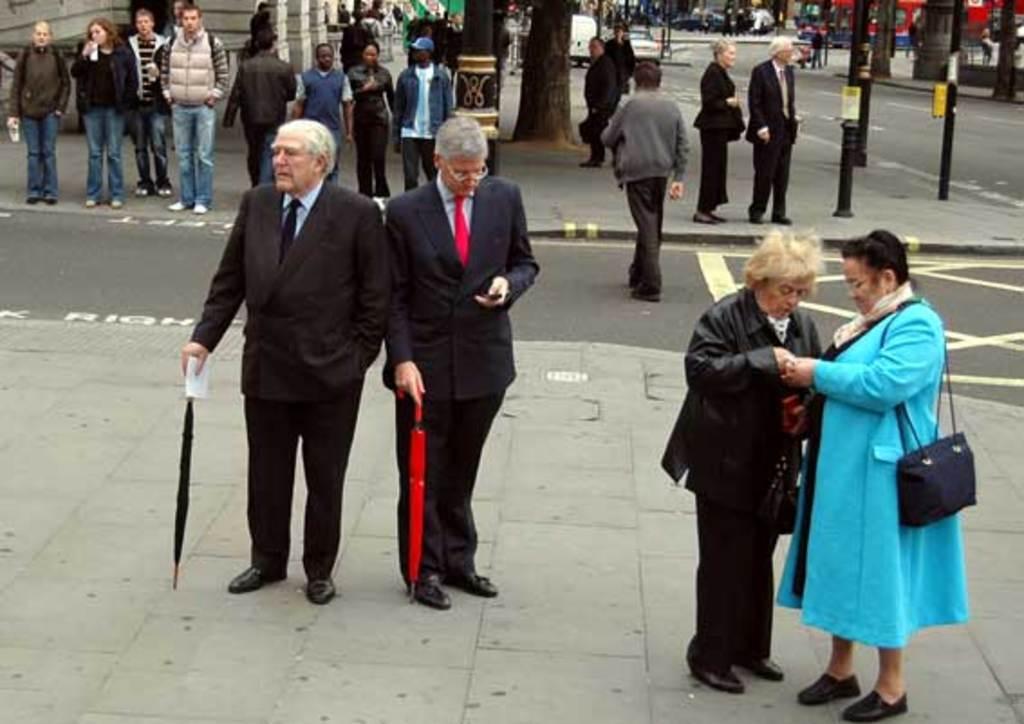Please provide a concise description of this image. On the left side two men are standing, they wore coats, trousers, ties, shirts. On the right side a woman is standing, she wore blue color sweater. In the middle there is a road. 